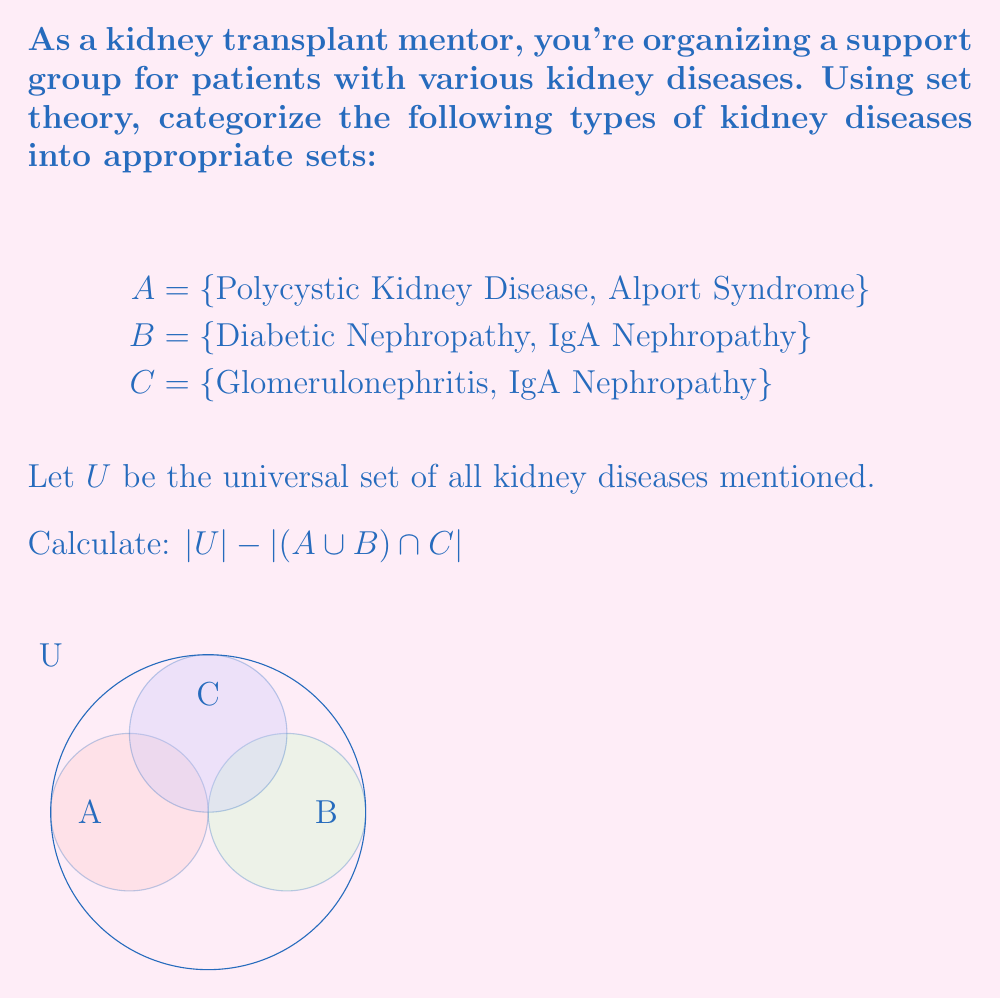Give your solution to this math problem. Let's approach this step-by-step:

1) First, identify the elements in each set:
   A = {Polycystic Kidney Disease, Alport Syndrome}
   B = {Diabetic Nephropathy, IgA Nephropathy}
   C = {Glomerulonephritis, IgA Nephropathy}

2) Find the universal set U:
   U = {Polycystic Kidney Disease, Alport Syndrome, Diabetic Nephropathy, IgA Nephropathy, Glomerulonephritis}

3) Calculate $|U|$:
   $|U| = 5$

4) Now, let's find $(A \cup B) \cap C$:
   A ∪ B = {Polycystic Kidney Disease, Alport Syndrome, Diabetic Nephropathy, IgA Nephropathy}
   (A ∪ B) ∩ C = {IgA Nephropathy}

5) Calculate $|(A \cup B) \cap C|$:
   $|(A \cup B) \cap C| = 1$

6) Finally, calculate $|U| - |(A \cup B) \cap C|$:
   $|U| - |(A \cup B) \cap C| = 5 - 1 = 4$

This result represents the number of kidney diseases in the universal set that are not common to both (A ∪ B) and C.
Answer: 4 